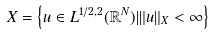<formula> <loc_0><loc_0><loc_500><loc_500>X = \left \{ u \in L ^ { 1 / 2 , 2 } ( \mathbb { R } ^ { N } ) | \| u \| _ { X } < \infty \right \}</formula> 